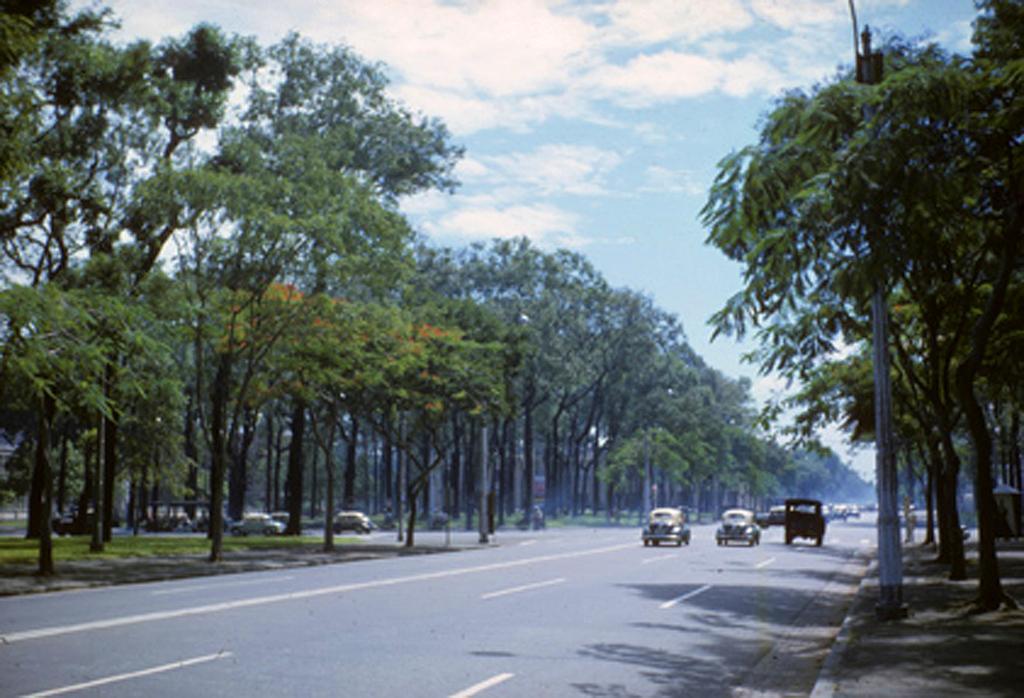In one or two sentences, can you explain what this image depicts? In this picture we can see some vehicles on the roads. On the right side of the road, there is a pole. On the left and right side of the image, there are trees. At the top of the image, there is the cloudy sky. 